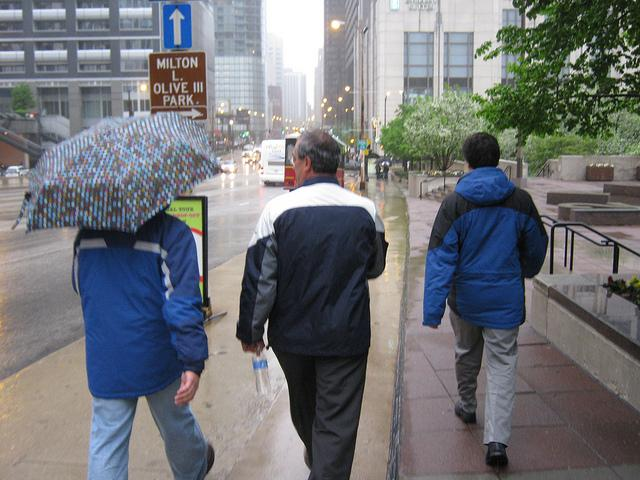What type of area is shown? Please explain your reasoning. urban. The tall buildings and street lights gives it away to where they are. 